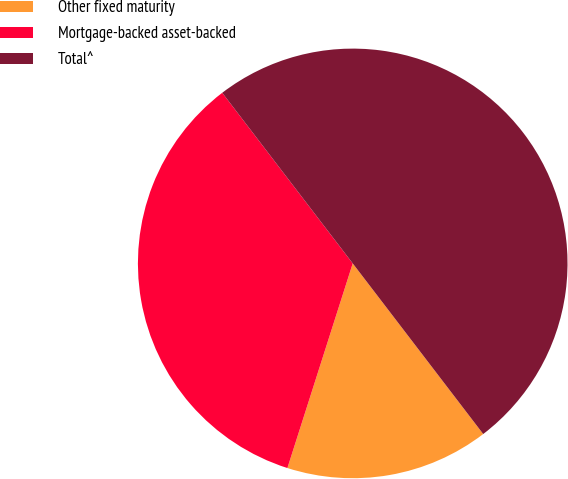<chart> <loc_0><loc_0><loc_500><loc_500><pie_chart><fcel>Other fixed maturity<fcel>Mortgage-backed asset-backed<fcel>Total^<nl><fcel>15.31%<fcel>34.69%<fcel>50.0%<nl></chart> 